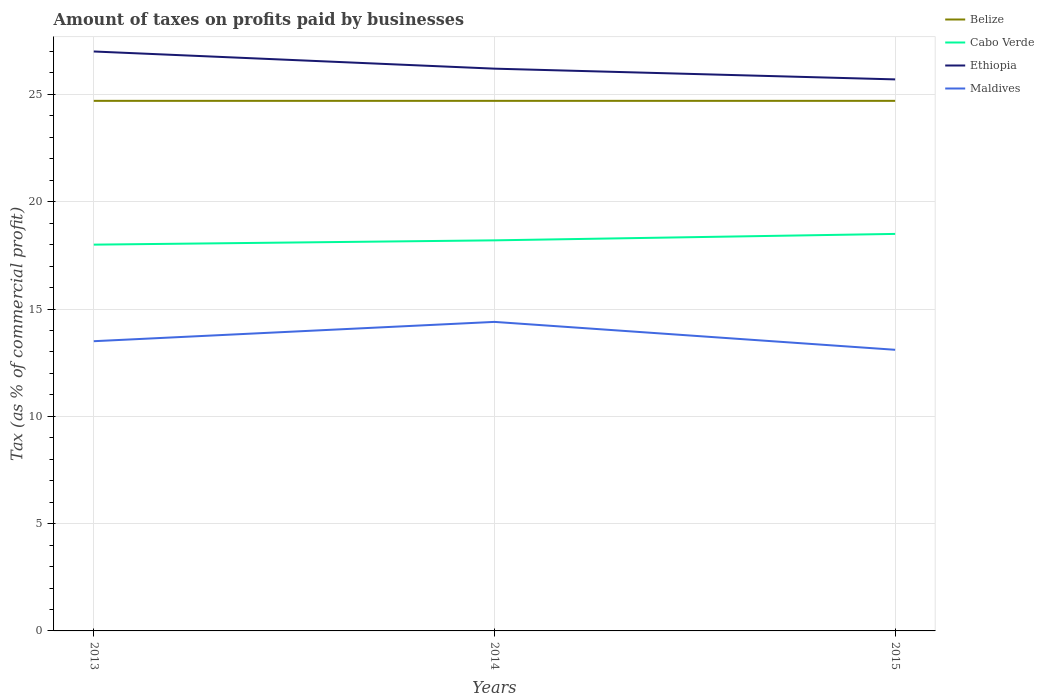In which year was the percentage of taxes paid by businesses in Maldives maximum?
Your response must be concise. 2015. What is the total percentage of taxes paid by businesses in Cabo Verde in the graph?
Give a very brief answer. -0.2. What is the difference between the highest and the second highest percentage of taxes paid by businesses in Cabo Verde?
Your answer should be compact. 0.5. Is the percentage of taxes paid by businesses in Maldives strictly greater than the percentage of taxes paid by businesses in Belize over the years?
Your response must be concise. Yes. How many years are there in the graph?
Offer a terse response. 3. Are the values on the major ticks of Y-axis written in scientific E-notation?
Keep it short and to the point. No. Where does the legend appear in the graph?
Your answer should be very brief. Top right. How many legend labels are there?
Provide a short and direct response. 4. How are the legend labels stacked?
Provide a short and direct response. Vertical. What is the title of the graph?
Keep it short and to the point. Amount of taxes on profits paid by businesses. Does "Jamaica" appear as one of the legend labels in the graph?
Provide a succinct answer. No. What is the label or title of the Y-axis?
Make the answer very short. Tax (as % of commercial profit). What is the Tax (as % of commercial profit) of Belize in 2013?
Offer a very short reply. 24.7. What is the Tax (as % of commercial profit) in Cabo Verde in 2013?
Give a very brief answer. 18. What is the Tax (as % of commercial profit) in Belize in 2014?
Keep it short and to the point. 24.7. What is the Tax (as % of commercial profit) in Ethiopia in 2014?
Your answer should be very brief. 26.2. What is the Tax (as % of commercial profit) of Maldives in 2014?
Your answer should be very brief. 14.4. What is the Tax (as % of commercial profit) in Belize in 2015?
Make the answer very short. 24.7. What is the Tax (as % of commercial profit) of Ethiopia in 2015?
Your answer should be compact. 25.7. What is the Tax (as % of commercial profit) of Maldives in 2015?
Make the answer very short. 13.1. Across all years, what is the maximum Tax (as % of commercial profit) of Belize?
Your answer should be compact. 24.7. Across all years, what is the minimum Tax (as % of commercial profit) of Belize?
Ensure brevity in your answer.  24.7. Across all years, what is the minimum Tax (as % of commercial profit) in Ethiopia?
Make the answer very short. 25.7. What is the total Tax (as % of commercial profit) of Belize in the graph?
Keep it short and to the point. 74.1. What is the total Tax (as % of commercial profit) in Cabo Verde in the graph?
Your answer should be very brief. 54.7. What is the total Tax (as % of commercial profit) in Ethiopia in the graph?
Keep it short and to the point. 78.9. What is the total Tax (as % of commercial profit) of Maldives in the graph?
Give a very brief answer. 41. What is the difference between the Tax (as % of commercial profit) in Cabo Verde in 2013 and that in 2014?
Your response must be concise. -0.2. What is the difference between the Tax (as % of commercial profit) in Ethiopia in 2013 and that in 2014?
Make the answer very short. 0.8. What is the difference between the Tax (as % of commercial profit) in Cabo Verde in 2013 and that in 2015?
Provide a succinct answer. -0.5. What is the difference between the Tax (as % of commercial profit) in Maldives in 2013 and that in 2015?
Ensure brevity in your answer.  0.4. What is the difference between the Tax (as % of commercial profit) of Belize in 2014 and that in 2015?
Keep it short and to the point. 0. What is the difference between the Tax (as % of commercial profit) in Cabo Verde in 2014 and that in 2015?
Ensure brevity in your answer.  -0.3. What is the difference between the Tax (as % of commercial profit) of Ethiopia in 2014 and that in 2015?
Ensure brevity in your answer.  0.5. What is the difference between the Tax (as % of commercial profit) of Belize in 2013 and the Tax (as % of commercial profit) of Ethiopia in 2014?
Provide a succinct answer. -1.5. What is the difference between the Tax (as % of commercial profit) in Belize in 2013 and the Tax (as % of commercial profit) in Maldives in 2014?
Your answer should be very brief. 10.3. What is the difference between the Tax (as % of commercial profit) in Ethiopia in 2013 and the Tax (as % of commercial profit) in Maldives in 2014?
Your answer should be compact. 12.6. What is the difference between the Tax (as % of commercial profit) in Belize in 2013 and the Tax (as % of commercial profit) in Cabo Verde in 2015?
Give a very brief answer. 6.2. What is the difference between the Tax (as % of commercial profit) in Belize in 2013 and the Tax (as % of commercial profit) in Maldives in 2015?
Ensure brevity in your answer.  11.6. What is the difference between the Tax (as % of commercial profit) in Cabo Verde in 2013 and the Tax (as % of commercial profit) in Maldives in 2015?
Keep it short and to the point. 4.9. What is the difference between the Tax (as % of commercial profit) of Belize in 2014 and the Tax (as % of commercial profit) of Ethiopia in 2015?
Your answer should be compact. -1. What is the difference between the Tax (as % of commercial profit) of Cabo Verde in 2014 and the Tax (as % of commercial profit) of Ethiopia in 2015?
Give a very brief answer. -7.5. What is the difference between the Tax (as % of commercial profit) in Ethiopia in 2014 and the Tax (as % of commercial profit) in Maldives in 2015?
Offer a terse response. 13.1. What is the average Tax (as % of commercial profit) of Belize per year?
Provide a succinct answer. 24.7. What is the average Tax (as % of commercial profit) in Cabo Verde per year?
Give a very brief answer. 18.23. What is the average Tax (as % of commercial profit) of Ethiopia per year?
Provide a short and direct response. 26.3. What is the average Tax (as % of commercial profit) in Maldives per year?
Provide a short and direct response. 13.67. In the year 2013, what is the difference between the Tax (as % of commercial profit) of Belize and Tax (as % of commercial profit) of Ethiopia?
Keep it short and to the point. -2.3. In the year 2013, what is the difference between the Tax (as % of commercial profit) of Cabo Verde and Tax (as % of commercial profit) of Maldives?
Your answer should be compact. 4.5. In the year 2013, what is the difference between the Tax (as % of commercial profit) of Ethiopia and Tax (as % of commercial profit) of Maldives?
Give a very brief answer. 13.5. In the year 2014, what is the difference between the Tax (as % of commercial profit) of Belize and Tax (as % of commercial profit) of Cabo Verde?
Your answer should be very brief. 6.5. In the year 2014, what is the difference between the Tax (as % of commercial profit) of Belize and Tax (as % of commercial profit) of Ethiopia?
Make the answer very short. -1.5. In the year 2014, what is the difference between the Tax (as % of commercial profit) in Cabo Verde and Tax (as % of commercial profit) in Ethiopia?
Provide a succinct answer. -8. In the year 2014, what is the difference between the Tax (as % of commercial profit) of Cabo Verde and Tax (as % of commercial profit) of Maldives?
Your response must be concise. 3.8. In the year 2014, what is the difference between the Tax (as % of commercial profit) of Ethiopia and Tax (as % of commercial profit) of Maldives?
Provide a short and direct response. 11.8. In the year 2015, what is the difference between the Tax (as % of commercial profit) of Belize and Tax (as % of commercial profit) of Cabo Verde?
Keep it short and to the point. 6.2. In the year 2015, what is the difference between the Tax (as % of commercial profit) in Belize and Tax (as % of commercial profit) in Ethiopia?
Offer a very short reply. -1. In the year 2015, what is the difference between the Tax (as % of commercial profit) of Cabo Verde and Tax (as % of commercial profit) of Ethiopia?
Ensure brevity in your answer.  -7.2. In the year 2015, what is the difference between the Tax (as % of commercial profit) of Ethiopia and Tax (as % of commercial profit) of Maldives?
Your answer should be compact. 12.6. What is the ratio of the Tax (as % of commercial profit) in Ethiopia in 2013 to that in 2014?
Provide a short and direct response. 1.03. What is the ratio of the Tax (as % of commercial profit) of Maldives in 2013 to that in 2014?
Give a very brief answer. 0.94. What is the ratio of the Tax (as % of commercial profit) in Ethiopia in 2013 to that in 2015?
Provide a succinct answer. 1.05. What is the ratio of the Tax (as % of commercial profit) in Maldives in 2013 to that in 2015?
Offer a terse response. 1.03. What is the ratio of the Tax (as % of commercial profit) in Belize in 2014 to that in 2015?
Your answer should be very brief. 1. What is the ratio of the Tax (as % of commercial profit) of Cabo Verde in 2014 to that in 2015?
Give a very brief answer. 0.98. What is the ratio of the Tax (as % of commercial profit) in Ethiopia in 2014 to that in 2015?
Your response must be concise. 1.02. What is the ratio of the Tax (as % of commercial profit) in Maldives in 2014 to that in 2015?
Keep it short and to the point. 1.1. What is the difference between the highest and the second highest Tax (as % of commercial profit) of Belize?
Ensure brevity in your answer.  0. What is the difference between the highest and the second highest Tax (as % of commercial profit) of Ethiopia?
Offer a very short reply. 0.8. 